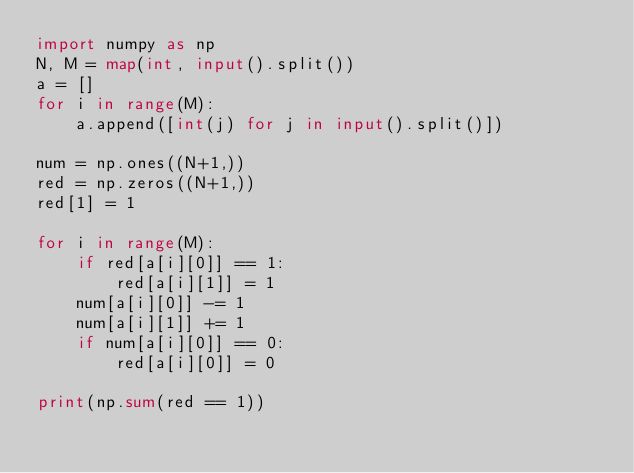Convert code to text. <code><loc_0><loc_0><loc_500><loc_500><_Python_>import numpy as np
N, M = map(int, input().split())
a = []
for i in range(M):
    a.append([int(j) for j in input().split()])

num = np.ones((N+1,))
red = np.zeros((N+1,))
red[1] = 1

for i in range(M):
    if red[a[i][0]] == 1:
        red[a[i][1]] = 1
    num[a[i][0]] -= 1
    num[a[i][1]] += 1
    if num[a[i][0]] == 0:
        red[a[i][0]] = 0

print(np.sum(red == 1))</code> 